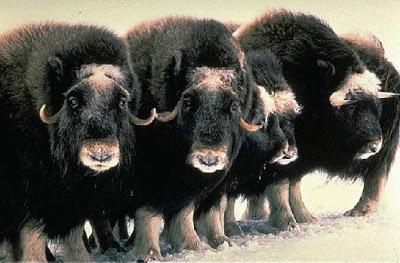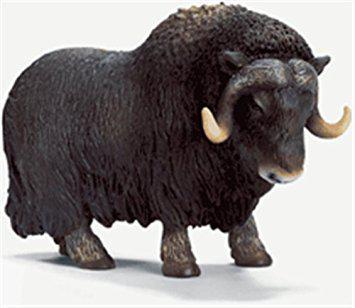The first image is the image on the left, the second image is the image on the right. Evaluate the accuracy of this statement regarding the images: "An image shows a man wielding a stick behind a plow pulled by two cattle.". Is it true? Answer yes or no. No. The first image is the image on the left, the second image is the image on the right. Examine the images to the left and right. Is the description "In one image, a farmer is guiding a plow that two animals with horns are pulling through a watery field." accurate? Answer yes or no. No. 